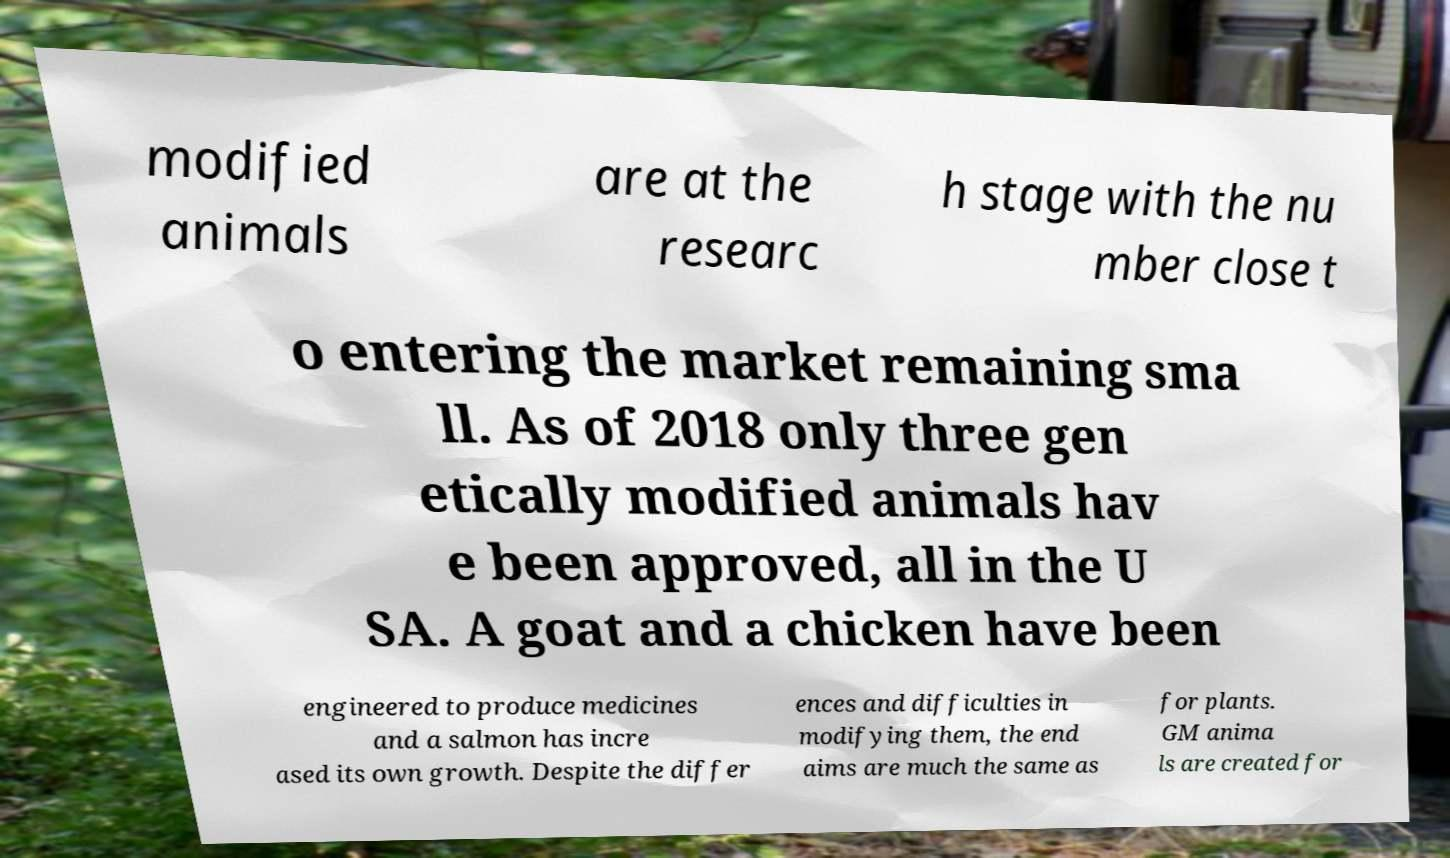There's text embedded in this image that I need extracted. Can you transcribe it verbatim? modified animals are at the researc h stage with the nu mber close t o entering the market remaining sma ll. As of 2018 only three gen etically modified animals hav e been approved, all in the U SA. A goat and a chicken have been engineered to produce medicines and a salmon has incre ased its own growth. Despite the differ ences and difficulties in modifying them, the end aims are much the same as for plants. GM anima ls are created for 